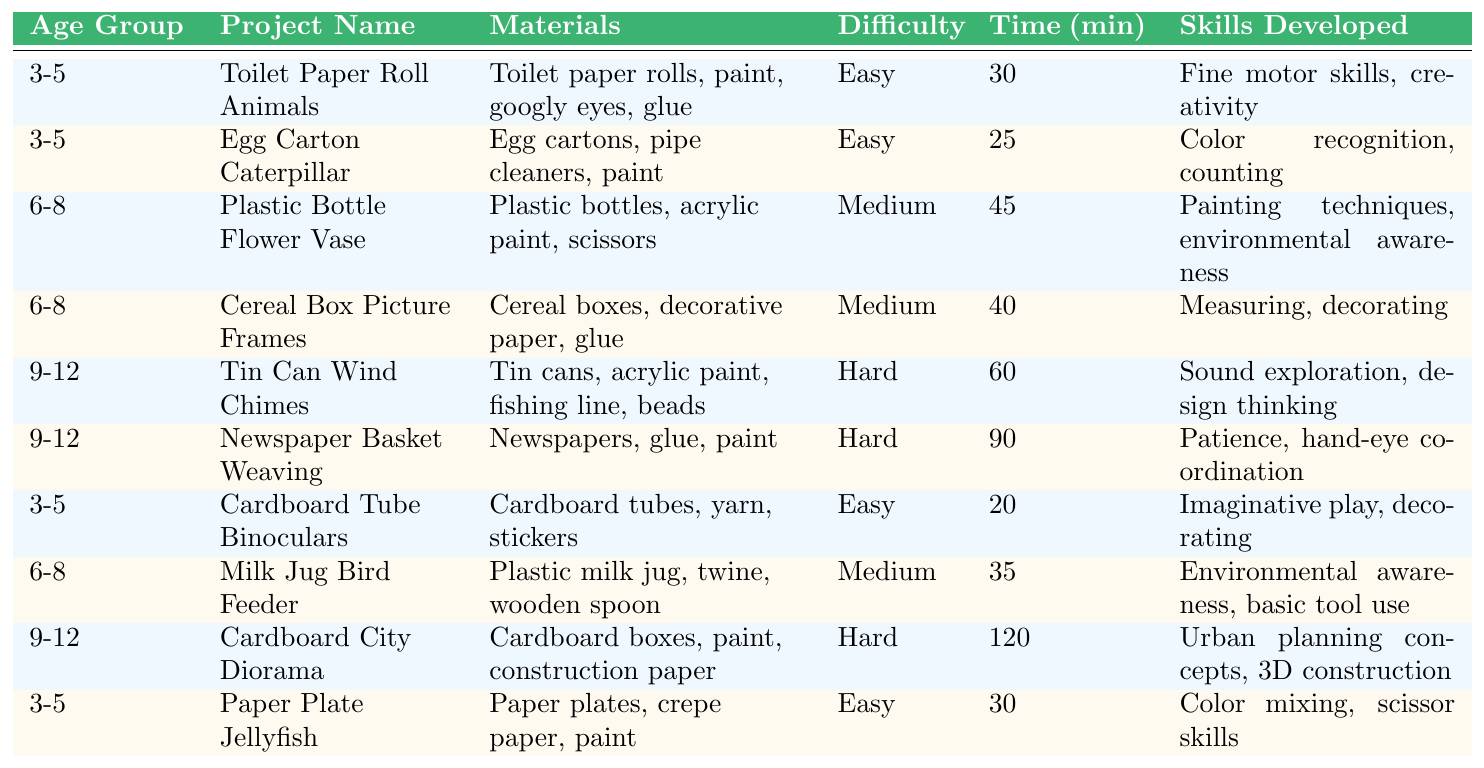What are the materials required for the "Egg Carton Caterpillar" project? The table lists the materials for the "Egg Carton Caterpillar" project as "Egg cartons, pipe cleaners, paint."
Answer: Egg cartons, pipe cleaners, paint How long does it take to complete the "Cereal Box Picture Frames" project? According to the table, the “Cereal Box Picture Frames” project requires 40 minutes to complete.
Answer: 40 minutes Are all the projects for ages 3-5 easy? The table shows that all projects for ages 3-5 listed are categorized as "Easy."
Answer: Yes What is the total time required for the two art projects targeted for ages 9-12? The projects for ages 9-12 are "Tin Can Wind Chimes" (60 minutes) and "Newspaper Basket Weaving" (90 minutes). Adding these, 60 + 90 = 150 minutes.
Answer: 150 minutes How many projects are listed for each age group? For ages 3-5, there are 5 projects. For ages 6-8, there are 3 projects. For ages 9-12, there are also 3 projects.
Answer: 5, 3, 3 Which age group has the highest difficulty level project? The table indicates that the "Cardboard City Diorama" is the hardest project with a "Hard" difficulty level, which is listed under the 9-12 age group.
Answer: 9-12 What skills are developed in the "Plastic Bottle Flower Vase" project? The table lists the skills developed from this project as "Painting techniques, environmental awareness."
Answer: Painting techniques, environmental awareness What is the average time required for projects targeted at children aged 6-8? The time required for the two projects in the 6-8 age group are 45 and 40 minutes respectively. The average is calculated as (45 + 40) / 2 = 42.5 minutes.
Answer: 42.5 minutes Is there any project that combines creativity and environmental awareness for ages 6-8? Yes, the "Milk Jug Bird Feeder" project develops environmental awareness and involves creativity in its execution.
Answer: Yes Which project requires more time, "Newspaper Basket Weaving" or "Toilet Paper Roll Animals"? "Newspaper Basket Weaving" requires 90 minutes while "Toilet Paper Roll Animals" requires only 30 minutes. Since 90 > 30, "Newspaper Basket Weaving" requires more time.
Answer: Newspaper Basket Weaving 